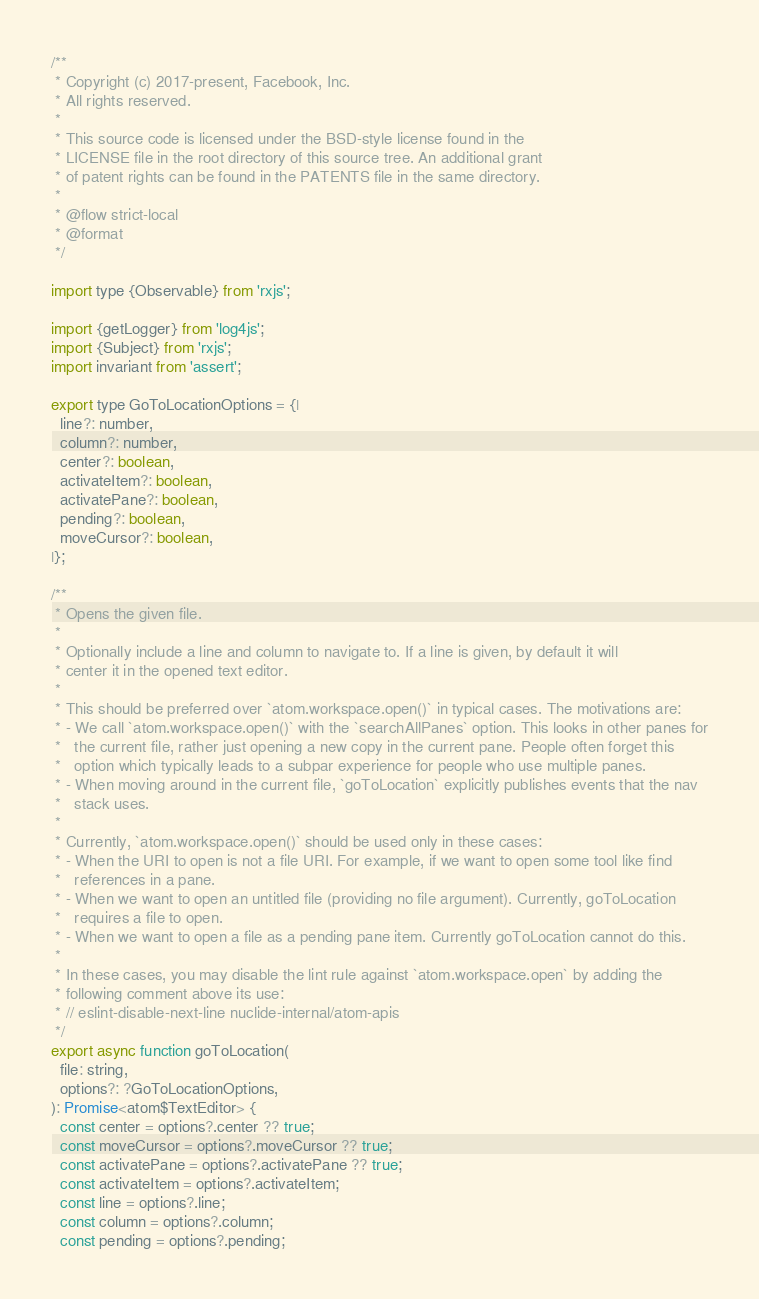<code> <loc_0><loc_0><loc_500><loc_500><_JavaScript_>/**
 * Copyright (c) 2017-present, Facebook, Inc.
 * All rights reserved.
 *
 * This source code is licensed under the BSD-style license found in the
 * LICENSE file in the root directory of this source tree. An additional grant
 * of patent rights can be found in the PATENTS file in the same directory.
 *
 * @flow strict-local
 * @format
 */

import type {Observable} from 'rxjs';

import {getLogger} from 'log4js';
import {Subject} from 'rxjs';
import invariant from 'assert';

export type GoToLocationOptions = {|
  line?: number,
  column?: number,
  center?: boolean,
  activateItem?: boolean,
  activatePane?: boolean,
  pending?: boolean,
  moveCursor?: boolean,
|};

/**
 * Opens the given file.
 *
 * Optionally include a line and column to navigate to. If a line is given, by default it will
 * center it in the opened text editor.
 *
 * This should be preferred over `atom.workspace.open()` in typical cases. The motivations are:
 * - We call `atom.workspace.open()` with the `searchAllPanes` option. This looks in other panes for
 *   the current file, rather just opening a new copy in the current pane. People often forget this
 *   option which typically leads to a subpar experience for people who use multiple panes.
 * - When moving around in the current file, `goToLocation` explicitly publishes events that the nav
 *   stack uses.
 *
 * Currently, `atom.workspace.open()` should be used only in these cases:
 * - When the URI to open is not a file URI. For example, if we want to open some tool like find
 *   references in a pane.
 * - When we want to open an untitled file (providing no file argument). Currently, goToLocation
 *   requires a file to open.
 * - When we want to open a file as a pending pane item. Currently goToLocation cannot do this.
 *
 * In these cases, you may disable the lint rule against `atom.workspace.open` by adding the
 * following comment above its use:
 * // eslint-disable-next-line nuclide-internal/atom-apis
 */
export async function goToLocation(
  file: string,
  options?: ?GoToLocationOptions,
): Promise<atom$TextEditor> {
  const center = options?.center ?? true;
  const moveCursor = options?.moveCursor ?? true;
  const activatePane = options?.activatePane ?? true;
  const activateItem = options?.activateItem;
  const line = options?.line;
  const column = options?.column;
  const pending = options?.pending;
</code> 